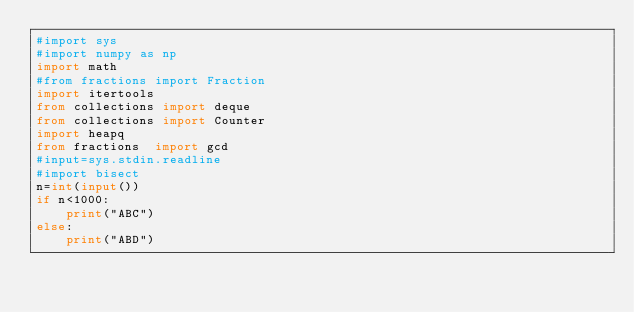<code> <loc_0><loc_0><loc_500><loc_500><_Python_>#import sys
#import numpy as np
import math
#from fractions import Fraction
import itertools
from collections import deque
from collections import Counter
import heapq
from fractions  import gcd
#input=sys.stdin.readline
#import bisect
n=int(input())
if n<1000:
    print("ABC")
else:
    print("ABD")</code> 